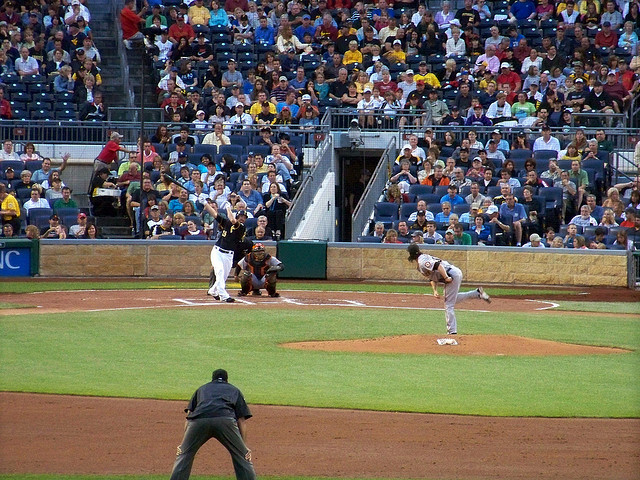Please identify all text content in this image. C 